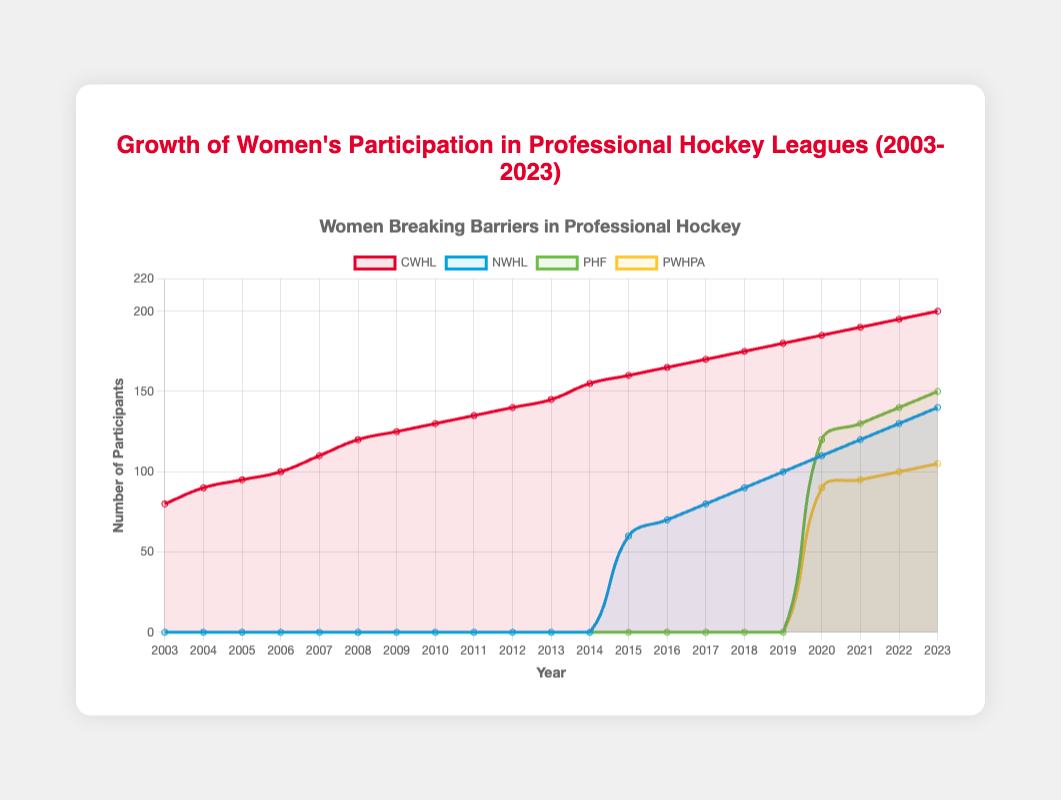What year did NWHL start to have participants? By observing the NWHL line, it remains at 0 until a noticeable increase in 2015. Hence, the first year with participants is 2015.
Answer: 2015 Which league had the highest number of participants in 2023? In 2023, examine the points at the end of each line. CWHL reaches 200, NWHL reaches 140, PHF reaches 150, and PWHPA reaches 105. CWHL is the highest among them.
Answer: CWHL How many total participants were there across all leagues in 2020? Sum the values of each league in 2020: CWHL (185) + NWHL (110) + PHF (120) + PWHPA (90). The total is 185 + 110 + 120 + 90 = 505.
Answer: 505 In which year did the PHF surpass the number of participants in the NWHL for the first time? Look for the year where PHF's line exceeds NWHL's line. This occurs in 2020, where PHF (120) surpasses NWHL (110).
Answer: 2020 Between 2013 and 2015, which league saw the highest increase in participation? Calculate the differences for each league between 2013 and 2015:
CWHL: 160 - 145 = 15
NWHL: 60 - 0 = 60
PHF: 0 - 0 = 0
PWHPA: 0 - 0 = 0
The NWHL had the highest increase (60 participants).
Answer: NWHL What is the difference in the number of participants between CWHL and PWHPA in 2019? CWHL has 180 participants in 2019 while PWHPA has 90. The difference is 180 - 90 = 90.
Answer: 90 Which color represents the PWHPA league in the chart? Examine the legend of the chart. The color corresponding to PWHPA is yellow.
Answer: Yellow What is the trend for CWHL participants from 2003 to 2023? The CWHL line shows a continuous upward trend from 80 participants in 2003 to 200 participants in 2023, indicating steady growth.
Answer: Steady growth In which year did both the PHF and PWHPA have participants for the first time? PHF began having participants in 2020, and PWHPA also started in 2020.
Answer: 2020 